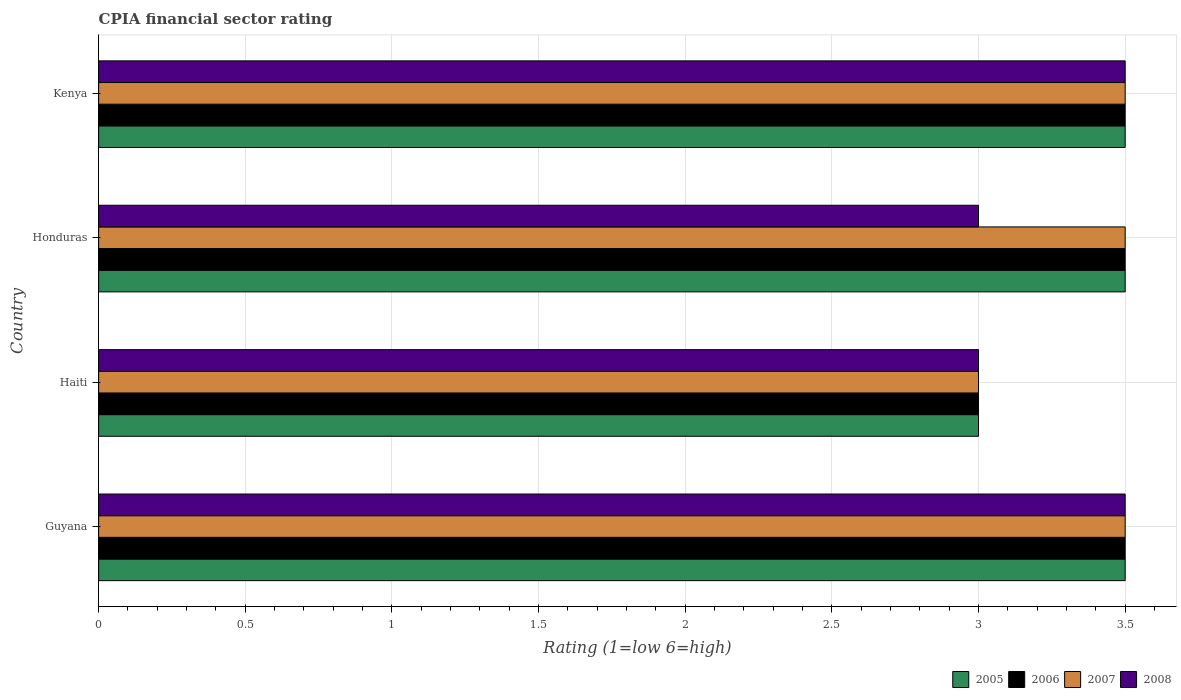How many groups of bars are there?
Your response must be concise. 4. Are the number of bars per tick equal to the number of legend labels?
Your answer should be compact. Yes. Are the number of bars on each tick of the Y-axis equal?
Keep it short and to the point. Yes. How many bars are there on the 1st tick from the top?
Offer a very short reply. 4. What is the label of the 2nd group of bars from the top?
Provide a succinct answer. Honduras. Across all countries, what is the maximum CPIA rating in 2007?
Ensure brevity in your answer.  3.5. Across all countries, what is the minimum CPIA rating in 2005?
Offer a very short reply. 3. In which country was the CPIA rating in 2007 maximum?
Your answer should be compact. Guyana. In which country was the CPIA rating in 2006 minimum?
Offer a terse response. Haiti. What is the difference between the CPIA rating in 2007 in Guyana and that in Kenya?
Ensure brevity in your answer.  0. What is the average CPIA rating in 2006 per country?
Provide a short and direct response. 3.38. What is the difference between the CPIA rating in 2007 and CPIA rating in 2006 in Kenya?
Keep it short and to the point. 0. In how many countries, is the CPIA rating in 2005 greater than 1.1 ?
Your answer should be compact. 4. What is the ratio of the CPIA rating in 2005 in Haiti to that in Honduras?
Offer a terse response. 0.86. Is the CPIA rating in 2006 in Haiti less than that in Kenya?
Your response must be concise. Yes. What is the difference between the highest and the second highest CPIA rating in 2007?
Give a very brief answer. 0. Is the sum of the CPIA rating in 2008 in Haiti and Kenya greater than the maximum CPIA rating in 2005 across all countries?
Your answer should be very brief. Yes. What does the 4th bar from the top in Haiti represents?
Your answer should be compact. 2005. Is it the case that in every country, the sum of the CPIA rating in 2008 and CPIA rating in 2006 is greater than the CPIA rating in 2005?
Your response must be concise. Yes. How many bars are there?
Your answer should be compact. 16. Are all the bars in the graph horizontal?
Your answer should be very brief. Yes. Are the values on the major ticks of X-axis written in scientific E-notation?
Offer a very short reply. No. Does the graph contain any zero values?
Offer a very short reply. No. Where does the legend appear in the graph?
Your answer should be compact. Bottom right. What is the title of the graph?
Provide a succinct answer. CPIA financial sector rating. Does "1968" appear as one of the legend labels in the graph?
Provide a short and direct response. No. What is the Rating (1=low 6=high) of 2005 in Guyana?
Provide a short and direct response. 3.5. What is the Rating (1=low 6=high) in 2007 in Guyana?
Offer a terse response. 3.5. What is the Rating (1=low 6=high) of 2008 in Guyana?
Provide a succinct answer. 3.5. What is the Rating (1=low 6=high) in 2007 in Haiti?
Offer a very short reply. 3. What is the Rating (1=low 6=high) in 2008 in Haiti?
Your response must be concise. 3. What is the Rating (1=low 6=high) in 2005 in Honduras?
Your answer should be very brief. 3.5. What is the Rating (1=low 6=high) in 2008 in Honduras?
Offer a terse response. 3. What is the Rating (1=low 6=high) of 2005 in Kenya?
Offer a very short reply. 3.5. What is the Rating (1=low 6=high) of 2006 in Kenya?
Make the answer very short. 3.5. Across all countries, what is the maximum Rating (1=low 6=high) in 2008?
Offer a terse response. 3.5. Across all countries, what is the minimum Rating (1=low 6=high) of 2005?
Your answer should be very brief. 3. Across all countries, what is the minimum Rating (1=low 6=high) of 2008?
Provide a short and direct response. 3. What is the total Rating (1=low 6=high) in 2006 in the graph?
Offer a terse response. 13.5. What is the total Rating (1=low 6=high) in 2007 in the graph?
Ensure brevity in your answer.  13.5. What is the total Rating (1=low 6=high) in 2008 in the graph?
Your answer should be compact. 13. What is the difference between the Rating (1=low 6=high) in 2006 in Guyana and that in Haiti?
Your answer should be compact. 0.5. What is the difference between the Rating (1=low 6=high) of 2007 in Guyana and that in Haiti?
Offer a terse response. 0.5. What is the difference between the Rating (1=low 6=high) of 2006 in Guyana and that in Honduras?
Give a very brief answer. 0. What is the difference between the Rating (1=low 6=high) of 2008 in Guyana and that in Honduras?
Give a very brief answer. 0.5. What is the difference between the Rating (1=low 6=high) of 2005 in Guyana and that in Kenya?
Give a very brief answer. 0. What is the difference between the Rating (1=low 6=high) in 2006 in Guyana and that in Kenya?
Provide a succinct answer. 0. What is the difference between the Rating (1=low 6=high) in 2007 in Guyana and that in Kenya?
Offer a terse response. 0. What is the difference between the Rating (1=low 6=high) of 2008 in Guyana and that in Kenya?
Ensure brevity in your answer.  0. What is the difference between the Rating (1=low 6=high) of 2006 in Haiti and that in Honduras?
Make the answer very short. -0.5. What is the difference between the Rating (1=low 6=high) in 2007 in Haiti and that in Honduras?
Offer a very short reply. -0.5. What is the difference between the Rating (1=low 6=high) in 2008 in Haiti and that in Honduras?
Give a very brief answer. 0. What is the difference between the Rating (1=low 6=high) of 2007 in Haiti and that in Kenya?
Provide a short and direct response. -0.5. What is the difference between the Rating (1=low 6=high) of 2008 in Haiti and that in Kenya?
Provide a succinct answer. -0.5. What is the difference between the Rating (1=low 6=high) in 2005 in Honduras and that in Kenya?
Give a very brief answer. 0. What is the difference between the Rating (1=low 6=high) in 2006 in Honduras and that in Kenya?
Give a very brief answer. 0. What is the difference between the Rating (1=low 6=high) of 2008 in Honduras and that in Kenya?
Ensure brevity in your answer.  -0.5. What is the difference between the Rating (1=low 6=high) of 2005 in Guyana and the Rating (1=low 6=high) of 2006 in Haiti?
Give a very brief answer. 0.5. What is the difference between the Rating (1=low 6=high) in 2005 in Guyana and the Rating (1=low 6=high) in 2007 in Haiti?
Make the answer very short. 0.5. What is the difference between the Rating (1=low 6=high) of 2005 in Guyana and the Rating (1=low 6=high) of 2006 in Honduras?
Offer a terse response. 0. What is the difference between the Rating (1=low 6=high) of 2005 in Guyana and the Rating (1=low 6=high) of 2007 in Honduras?
Offer a very short reply. 0. What is the difference between the Rating (1=low 6=high) in 2005 in Guyana and the Rating (1=low 6=high) in 2008 in Honduras?
Keep it short and to the point. 0.5. What is the difference between the Rating (1=low 6=high) in 2006 in Guyana and the Rating (1=low 6=high) in 2007 in Honduras?
Your response must be concise. 0. What is the difference between the Rating (1=low 6=high) of 2007 in Guyana and the Rating (1=low 6=high) of 2008 in Honduras?
Offer a terse response. 0.5. What is the difference between the Rating (1=low 6=high) in 2005 in Guyana and the Rating (1=low 6=high) in 2008 in Kenya?
Provide a succinct answer. 0. What is the difference between the Rating (1=low 6=high) of 2006 in Guyana and the Rating (1=low 6=high) of 2008 in Kenya?
Keep it short and to the point. 0. What is the difference between the Rating (1=low 6=high) in 2007 in Guyana and the Rating (1=low 6=high) in 2008 in Kenya?
Offer a terse response. 0. What is the difference between the Rating (1=low 6=high) in 2005 in Haiti and the Rating (1=low 6=high) in 2006 in Honduras?
Offer a terse response. -0.5. What is the difference between the Rating (1=low 6=high) of 2006 in Haiti and the Rating (1=low 6=high) of 2008 in Honduras?
Your answer should be compact. 0. What is the difference between the Rating (1=low 6=high) of 2007 in Haiti and the Rating (1=low 6=high) of 2008 in Honduras?
Make the answer very short. 0. What is the difference between the Rating (1=low 6=high) in 2005 in Haiti and the Rating (1=low 6=high) in 2006 in Kenya?
Your answer should be compact. -0.5. What is the difference between the Rating (1=low 6=high) in 2005 in Haiti and the Rating (1=low 6=high) in 2007 in Kenya?
Provide a short and direct response. -0.5. What is the difference between the Rating (1=low 6=high) in 2007 in Haiti and the Rating (1=low 6=high) in 2008 in Kenya?
Make the answer very short. -0.5. What is the difference between the Rating (1=low 6=high) of 2005 in Honduras and the Rating (1=low 6=high) of 2007 in Kenya?
Offer a very short reply. 0. What is the difference between the Rating (1=low 6=high) of 2007 in Honduras and the Rating (1=low 6=high) of 2008 in Kenya?
Your response must be concise. 0. What is the average Rating (1=low 6=high) in 2005 per country?
Offer a terse response. 3.38. What is the average Rating (1=low 6=high) in 2006 per country?
Provide a succinct answer. 3.38. What is the average Rating (1=low 6=high) of 2007 per country?
Keep it short and to the point. 3.38. What is the difference between the Rating (1=low 6=high) in 2006 and Rating (1=low 6=high) in 2007 in Guyana?
Your response must be concise. 0. What is the difference between the Rating (1=low 6=high) in 2005 and Rating (1=low 6=high) in 2006 in Haiti?
Offer a very short reply. 0. What is the difference between the Rating (1=low 6=high) of 2005 and Rating (1=low 6=high) of 2007 in Haiti?
Offer a very short reply. 0. What is the difference between the Rating (1=low 6=high) in 2005 and Rating (1=low 6=high) in 2008 in Haiti?
Provide a succinct answer. 0. What is the difference between the Rating (1=low 6=high) in 2006 and Rating (1=low 6=high) in 2007 in Haiti?
Provide a succinct answer. 0. What is the difference between the Rating (1=low 6=high) of 2006 and Rating (1=low 6=high) of 2008 in Haiti?
Your answer should be compact. 0. What is the difference between the Rating (1=low 6=high) of 2007 and Rating (1=low 6=high) of 2008 in Haiti?
Give a very brief answer. 0. What is the difference between the Rating (1=low 6=high) in 2005 and Rating (1=low 6=high) in 2008 in Honduras?
Your response must be concise. 0.5. What is the difference between the Rating (1=low 6=high) in 2007 and Rating (1=low 6=high) in 2008 in Honduras?
Give a very brief answer. 0.5. What is the difference between the Rating (1=low 6=high) of 2005 and Rating (1=low 6=high) of 2007 in Kenya?
Offer a very short reply. 0. What is the ratio of the Rating (1=low 6=high) of 2007 in Guyana to that in Haiti?
Your answer should be very brief. 1.17. What is the ratio of the Rating (1=low 6=high) in 2008 in Guyana to that in Haiti?
Give a very brief answer. 1.17. What is the ratio of the Rating (1=low 6=high) in 2005 in Guyana to that in Honduras?
Your response must be concise. 1. What is the ratio of the Rating (1=low 6=high) of 2006 in Guyana to that in Honduras?
Offer a very short reply. 1. What is the ratio of the Rating (1=low 6=high) of 2008 in Guyana to that in Honduras?
Your answer should be compact. 1.17. What is the ratio of the Rating (1=low 6=high) of 2005 in Guyana to that in Kenya?
Give a very brief answer. 1. What is the ratio of the Rating (1=low 6=high) in 2005 in Haiti to that in Honduras?
Provide a short and direct response. 0.86. What is the ratio of the Rating (1=low 6=high) in 2007 in Haiti to that in Honduras?
Ensure brevity in your answer.  0.86. What is the ratio of the Rating (1=low 6=high) of 2005 in Honduras to that in Kenya?
Make the answer very short. 1. What is the ratio of the Rating (1=low 6=high) in 2006 in Honduras to that in Kenya?
Provide a short and direct response. 1. What is the difference between the highest and the second highest Rating (1=low 6=high) of 2006?
Ensure brevity in your answer.  0. What is the difference between the highest and the second highest Rating (1=low 6=high) in 2008?
Keep it short and to the point. 0. 